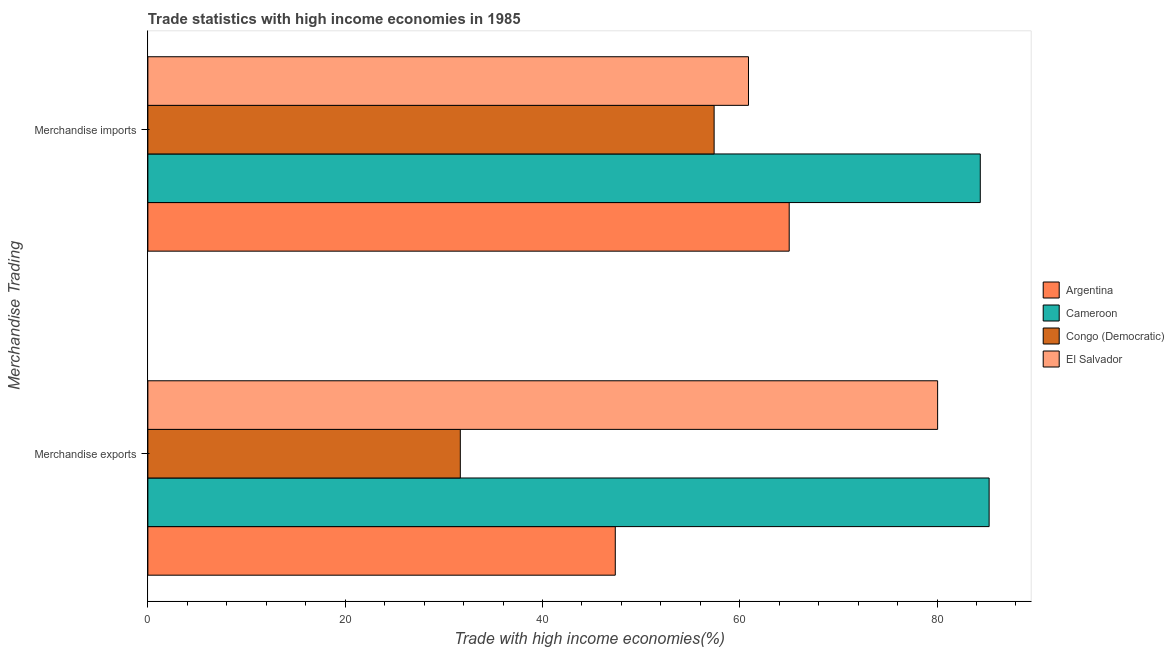How many different coloured bars are there?
Make the answer very short. 4. How many bars are there on the 1st tick from the bottom?
Offer a terse response. 4. What is the label of the 2nd group of bars from the top?
Give a very brief answer. Merchandise exports. What is the merchandise imports in Congo (Democratic)?
Give a very brief answer. 57.4. Across all countries, what is the maximum merchandise imports?
Offer a terse response. 84.38. Across all countries, what is the minimum merchandise imports?
Keep it short and to the point. 57.4. In which country was the merchandise exports maximum?
Your answer should be compact. Cameroon. In which country was the merchandise imports minimum?
Your answer should be compact. Congo (Democratic). What is the total merchandise imports in the graph?
Your answer should be very brief. 267.68. What is the difference between the merchandise imports in Argentina and that in Cameroon?
Your response must be concise. -19.37. What is the difference between the merchandise exports in Congo (Democratic) and the merchandise imports in Argentina?
Your answer should be compact. -33.34. What is the average merchandise imports per country?
Your response must be concise. 66.92. What is the difference between the merchandise imports and merchandise exports in Congo (Democratic)?
Provide a short and direct response. 25.73. In how many countries, is the merchandise exports greater than 32 %?
Your answer should be very brief. 3. What is the ratio of the merchandise exports in El Salvador to that in Congo (Democratic)?
Your answer should be compact. 2.53. Is the merchandise imports in Congo (Democratic) less than that in El Salvador?
Offer a very short reply. Yes. What does the 2nd bar from the top in Merchandise exports represents?
Keep it short and to the point. Congo (Democratic). What does the 4th bar from the bottom in Merchandise imports represents?
Keep it short and to the point. El Salvador. How many bars are there?
Your response must be concise. 8. Are the values on the major ticks of X-axis written in scientific E-notation?
Give a very brief answer. No. Does the graph contain any zero values?
Give a very brief answer. No. Does the graph contain grids?
Offer a very short reply. No. How many legend labels are there?
Offer a very short reply. 4. How are the legend labels stacked?
Your answer should be compact. Vertical. What is the title of the graph?
Offer a terse response. Trade statistics with high income economies in 1985. Does "Marshall Islands" appear as one of the legend labels in the graph?
Your answer should be compact. No. What is the label or title of the X-axis?
Make the answer very short. Trade with high income economies(%). What is the label or title of the Y-axis?
Provide a short and direct response. Merchandise Trading. What is the Trade with high income economies(%) of Argentina in Merchandise exports?
Your response must be concise. 47.38. What is the Trade with high income economies(%) in Cameroon in Merchandise exports?
Your answer should be compact. 85.28. What is the Trade with high income economies(%) in Congo (Democratic) in Merchandise exports?
Give a very brief answer. 31.67. What is the Trade with high income economies(%) of El Salvador in Merchandise exports?
Keep it short and to the point. 80.06. What is the Trade with high income economies(%) in Argentina in Merchandise imports?
Keep it short and to the point. 65.01. What is the Trade with high income economies(%) in Cameroon in Merchandise imports?
Your answer should be compact. 84.38. What is the Trade with high income economies(%) of Congo (Democratic) in Merchandise imports?
Provide a short and direct response. 57.4. What is the Trade with high income economies(%) of El Salvador in Merchandise imports?
Keep it short and to the point. 60.88. Across all Merchandise Trading, what is the maximum Trade with high income economies(%) of Argentina?
Ensure brevity in your answer.  65.01. Across all Merchandise Trading, what is the maximum Trade with high income economies(%) of Cameroon?
Give a very brief answer. 85.28. Across all Merchandise Trading, what is the maximum Trade with high income economies(%) in Congo (Democratic)?
Give a very brief answer. 57.4. Across all Merchandise Trading, what is the maximum Trade with high income economies(%) of El Salvador?
Give a very brief answer. 80.06. Across all Merchandise Trading, what is the minimum Trade with high income economies(%) in Argentina?
Provide a succinct answer. 47.38. Across all Merchandise Trading, what is the minimum Trade with high income economies(%) of Cameroon?
Your answer should be compact. 84.38. Across all Merchandise Trading, what is the minimum Trade with high income economies(%) of Congo (Democratic)?
Your answer should be compact. 31.67. Across all Merchandise Trading, what is the minimum Trade with high income economies(%) in El Salvador?
Provide a succinct answer. 60.88. What is the total Trade with high income economies(%) in Argentina in the graph?
Give a very brief answer. 112.39. What is the total Trade with high income economies(%) of Cameroon in the graph?
Provide a short and direct response. 169.66. What is the total Trade with high income economies(%) of Congo (Democratic) in the graph?
Offer a terse response. 89.07. What is the total Trade with high income economies(%) in El Salvador in the graph?
Give a very brief answer. 140.94. What is the difference between the Trade with high income economies(%) of Argentina in Merchandise exports and that in Merchandise imports?
Offer a very short reply. -17.63. What is the difference between the Trade with high income economies(%) in Cameroon in Merchandise exports and that in Merchandise imports?
Your answer should be compact. 0.9. What is the difference between the Trade with high income economies(%) in Congo (Democratic) in Merchandise exports and that in Merchandise imports?
Offer a very short reply. -25.73. What is the difference between the Trade with high income economies(%) in El Salvador in Merchandise exports and that in Merchandise imports?
Ensure brevity in your answer.  19.17. What is the difference between the Trade with high income economies(%) of Argentina in Merchandise exports and the Trade with high income economies(%) of Cameroon in Merchandise imports?
Provide a succinct answer. -37. What is the difference between the Trade with high income economies(%) in Argentina in Merchandise exports and the Trade with high income economies(%) in Congo (Democratic) in Merchandise imports?
Your answer should be compact. -10.02. What is the difference between the Trade with high income economies(%) of Argentina in Merchandise exports and the Trade with high income economies(%) of El Salvador in Merchandise imports?
Provide a succinct answer. -13.5. What is the difference between the Trade with high income economies(%) in Cameroon in Merchandise exports and the Trade with high income economies(%) in Congo (Democratic) in Merchandise imports?
Your answer should be very brief. 27.88. What is the difference between the Trade with high income economies(%) of Cameroon in Merchandise exports and the Trade with high income economies(%) of El Salvador in Merchandise imports?
Ensure brevity in your answer.  24.39. What is the difference between the Trade with high income economies(%) of Congo (Democratic) in Merchandise exports and the Trade with high income economies(%) of El Salvador in Merchandise imports?
Offer a very short reply. -29.21. What is the average Trade with high income economies(%) in Argentina per Merchandise Trading?
Your response must be concise. 56.2. What is the average Trade with high income economies(%) of Cameroon per Merchandise Trading?
Provide a short and direct response. 84.83. What is the average Trade with high income economies(%) in Congo (Democratic) per Merchandise Trading?
Your response must be concise. 44.54. What is the average Trade with high income economies(%) in El Salvador per Merchandise Trading?
Ensure brevity in your answer.  70.47. What is the difference between the Trade with high income economies(%) of Argentina and Trade with high income economies(%) of Cameroon in Merchandise exports?
Make the answer very short. -37.9. What is the difference between the Trade with high income economies(%) in Argentina and Trade with high income economies(%) in Congo (Democratic) in Merchandise exports?
Provide a succinct answer. 15.71. What is the difference between the Trade with high income economies(%) in Argentina and Trade with high income economies(%) in El Salvador in Merchandise exports?
Make the answer very short. -32.68. What is the difference between the Trade with high income economies(%) of Cameroon and Trade with high income economies(%) of Congo (Democratic) in Merchandise exports?
Provide a short and direct response. 53.61. What is the difference between the Trade with high income economies(%) of Cameroon and Trade with high income economies(%) of El Salvador in Merchandise exports?
Provide a succinct answer. 5.22. What is the difference between the Trade with high income economies(%) of Congo (Democratic) and Trade with high income economies(%) of El Salvador in Merchandise exports?
Keep it short and to the point. -48.39. What is the difference between the Trade with high income economies(%) of Argentina and Trade with high income economies(%) of Cameroon in Merchandise imports?
Your response must be concise. -19.37. What is the difference between the Trade with high income economies(%) in Argentina and Trade with high income economies(%) in Congo (Democratic) in Merchandise imports?
Make the answer very short. 7.61. What is the difference between the Trade with high income economies(%) in Argentina and Trade with high income economies(%) in El Salvador in Merchandise imports?
Your response must be concise. 4.13. What is the difference between the Trade with high income economies(%) in Cameroon and Trade with high income economies(%) in Congo (Democratic) in Merchandise imports?
Your answer should be very brief. 26.98. What is the difference between the Trade with high income economies(%) of Cameroon and Trade with high income economies(%) of El Salvador in Merchandise imports?
Your response must be concise. 23.5. What is the difference between the Trade with high income economies(%) of Congo (Democratic) and Trade with high income economies(%) of El Salvador in Merchandise imports?
Provide a succinct answer. -3.48. What is the ratio of the Trade with high income economies(%) of Argentina in Merchandise exports to that in Merchandise imports?
Your response must be concise. 0.73. What is the ratio of the Trade with high income economies(%) of Cameroon in Merchandise exports to that in Merchandise imports?
Your answer should be very brief. 1.01. What is the ratio of the Trade with high income economies(%) in Congo (Democratic) in Merchandise exports to that in Merchandise imports?
Give a very brief answer. 0.55. What is the ratio of the Trade with high income economies(%) of El Salvador in Merchandise exports to that in Merchandise imports?
Make the answer very short. 1.31. What is the difference between the highest and the second highest Trade with high income economies(%) in Argentina?
Offer a terse response. 17.63. What is the difference between the highest and the second highest Trade with high income economies(%) in Cameroon?
Give a very brief answer. 0.9. What is the difference between the highest and the second highest Trade with high income economies(%) in Congo (Democratic)?
Offer a terse response. 25.73. What is the difference between the highest and the second highest Trade with high income economies(%) in El Salvador?
Give a very brief answer. 19.17. What is the difference between the highest and the lowest Trade with high income economies(%) in Argentina?
Your answer should be compact. 17.63. What is the difference between the highest and the lowest Trade with high income economies(%) in Cameroon?
Provide a short and direct response. 0.9. What is the difference between the highest and the lowest Trade with high income economies(%) in Congo (Democratic)?
Your response must be concise. 25.73. What is the difference between the highest and the lowest Trade with high income economies(%) of El Salvador?
Provide a short and direct response. 19.17. 